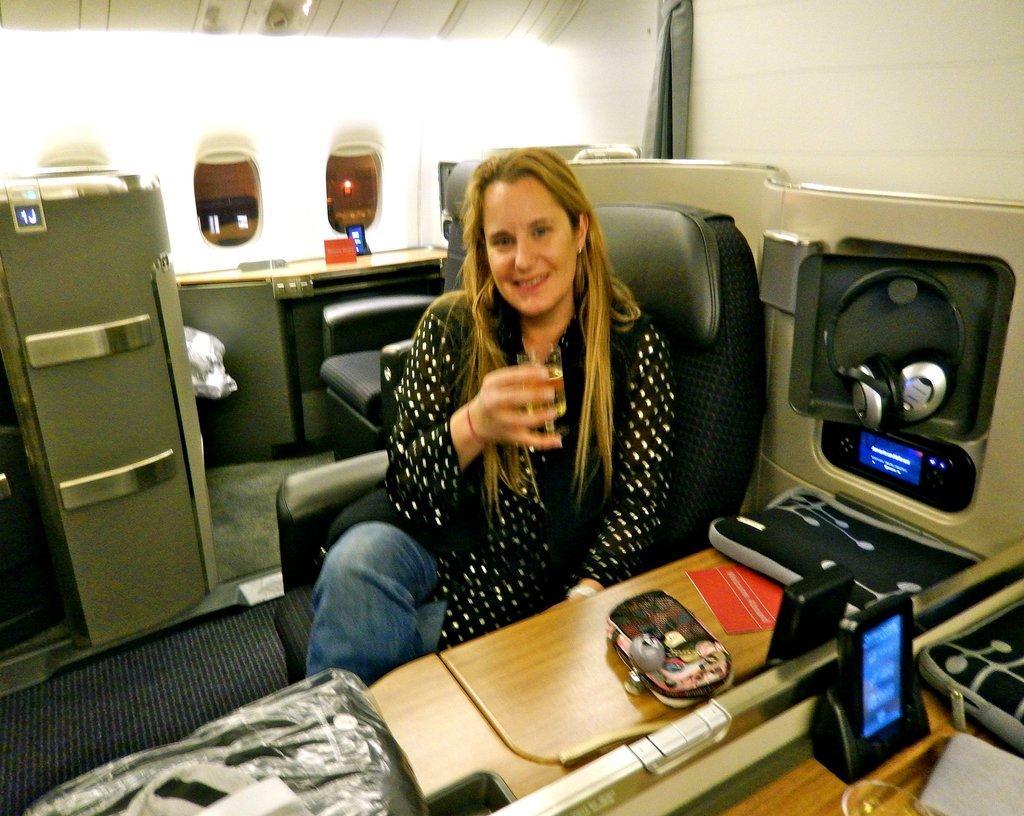Describe this image in one or two sentences. This is an inside view. In the middle of the image there is a woman sitting on a chair, holding a glass in the hand, smiling and giving pose for the picture. In front of her there is a table. On the table, I can see a wallet, paper, mobile and some other objects. In the background there is a chair and table. On the right side, I can see the wall. 